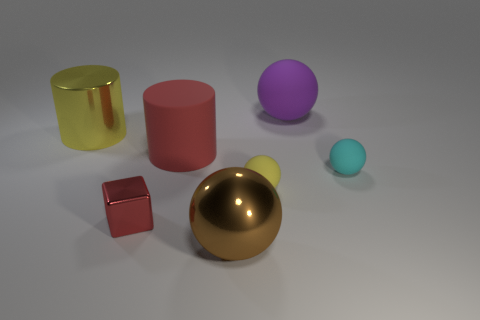How many other things have the same shape as the large yellow object?
Make the answer very short. 1. Is the size of the brown thing the same as the purple object behind the brown shiny object?
Provide a short and direct response. Yes. The yellow object that is to the right of the red thing to the right of the tiny metal object is what shape?
Offer a very short reply. Sphere. Are there fewer cyan matte things that are to the left of the block than cyan objects?
Your response must be concise. Yes. What shape is the tiny rubber thing that is the same color as the big shiny cylinder?
Ensure brevity in your answer.  Sphere. What number of cyan metallic things have the same size as the red cube?
Ensure brevity in your answer.  0. The metallic thing that is in front of the tiny red object has what shape?
Give a very brief answer. Sphere. Is the number of red things less than the number of matte spheres?
Keep it short and to the point. Yes. Is there anything else of the same color as the block?
Keep it short and to the point. Yes. There is a rubber sphere on the left side of the purple object; what size is it?
Keep it short and to the point. Small. 